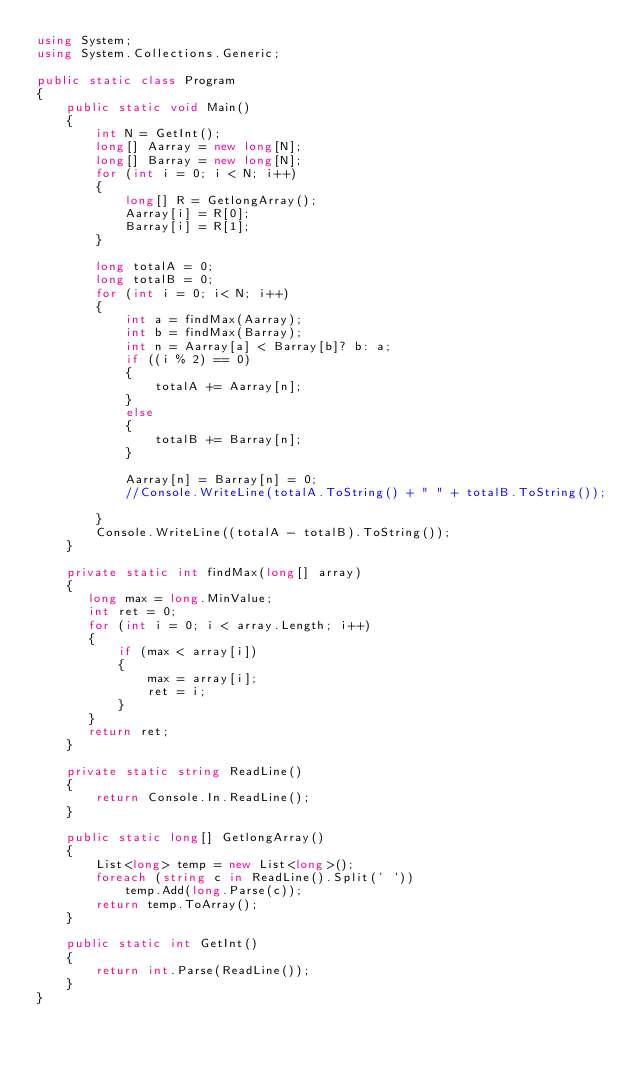Convert code to text. <code><loc_0><loc_0><loc_500><loc_500><_C#_>using System;
using System.Collections.Generic;
             
public static class Program
{
    public static void Main()
    {
        int N = GetInt();
        long[] Aarray = new long[N];
        long[] Barray = new long[N];
        for (int i = 0; i < N; i++)
        {
            long[] R = GetlongArray();
            Aarray[i] = R[0];
            Barray[i] = R[1];
        }

        long totalA = 0;
        long totalB = 0;
        for (int i = 0; i< N; i++)
        {
            int a = findMax(Aarray);
            int b = findMax(Barray);
            int n = Aarray[a] < Barray[b]? b: a;
            if ((i % 2) == 0)
            {
                totalA += Aarray[n];
            }
            else
            {
                totalB += Barray[n];
            }
            
            Aarray[n] = Barray[n] = 0;
            //Console.WriteLine(totalA.ToString() + " " + totalB.ToString());
          
        }
        Console.WriteLine((totalA - totalB).ToString());
    }
  
    private static int findMax(long[] array)
    {
       long max = long.MinValue;
       int ret = 0;
       for (int i = 0; i < array.Length; i++)
       {
           if (max < array[i])
           {
               max = array[i];
               ret = i;
           }
       }
       return ret;
    }
    
    private static string ReadLine()
    {
    	return Console.In.ReadLine();
    }
    
    public static long[] GetlongArray()
    {
    	List<long> temp = new List<long>();
    	foreach (string c in ReadLine().Split(' '))
            temp.Add(long.Parse(c));
        return temp.ToArray();
    }
    
    public static int GetInt()
    {
    	return int.Parse(ReadLine());
    }
}</code> 